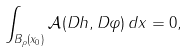Convert formula to latex. <formula><loc_0><loc_0><loc_500><loc_500>\int _ { B _ { \rho } ( x _ { 0 } ) } { \mathcal { A } } ( D h , D \varphi ) \, d x = 0 ,</formula> 